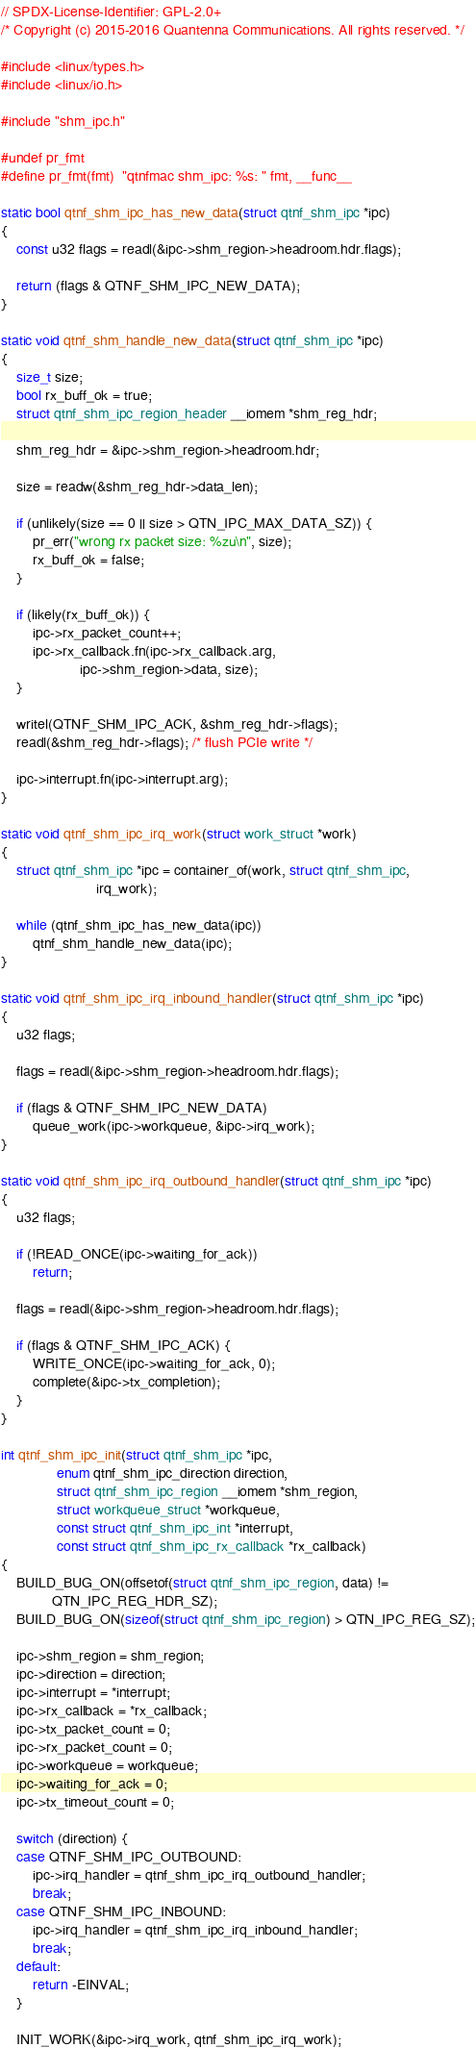<code> <loc_0><loc_0><loc_500><loc_500><_C_>// SPDX-License-Identifier: GPL-2.0+
/* Copyright (c) 2015-2016 Quantenna Communications. All rights reserved. */

#include <linux/types.h>
#include <linux/io.h>

#include "shm_ipc.h"

#undef pr_fmt
#define pr_fmt(fmt)	"qtnfmac shm_ipc: %s: " fmt, __func__

static bool qtnf_shm_ipc_has_new_data(struct qtnf_shm_ipc *ipc)
{
	const u32 flags = readl(&ipc->shm_region->headroom.hdr.flags);

	return (flags & QTNF_SHM_IPC_NEW_DATA);
}

static void qtnf_shm_handle_new_data(struct qtnf_shm_ipc *ipc)
{
	size_t size;
	bool rx_buff_ok = true;
	struct qtnf_shm_ipc_region_header __iomem *shm_reg_hdr;

	shm_reg_hdr = &ipc->shm_region->headroom.hdr;

	size = readw(&shm_reg_hdr->data_len);

	if (unlikely(size == 0 || size > QTN_IPC_MAX_DATA_SZ)) {
		pr_err("wrong rx packet size: %zu\n", size);
		rx_buff_ok = false;
	}

	if (likely(rx_buff_ok)) {
		ipc->rx_packet_count++;
		ipc->rx_callback.fn(ipc->rx_callback.arg,
				    ipc->shm_region->data, size);
	}

	writel(QTNF_SHM_IPC_ACK, &shm_reg_hdr->flags);
	readl(&shm_reg_hdr->flags); /* flush PCIe write */

	ipc->interrupt.fn(ipc->interrupt.arg);
}

static void qtnf_shm_ipc_irq_work(struct work_struct *work)
{
	struct qtnf_shm_ipc *ipc = container_of(work, struct qtnf_shm_ipc,
						irq_work);

	while (qtnf_shm_ipc_has_new_data(ipc))
		qtnf_shm_handle_new_data(ipc);
}

static void qtnf_shm_ipc_irq_inbound_handler(struct qtnf_shm_ipc *ipc)
{
	u32 flags;

	flags = readl(&ipc->shm_region->headroom.hdr.flags);

	if (flags & QTNF_SHM_IPC_NEW_DATA)
		queue_work(ipc->workqueue, &ipc->irq_work);
}

static void qtnf_shm_ipc_irq_outbound_handler(struct qtnf_shm_ipc *ipc)
{
	u32 flags;

	if (!READ_ONCE(ipc->waiting_for_ack))
		return;

	flags = readl(&ipc->shm_region->headroom.hdr.flags);

	if (flags & QTNF_SHM_IPC_ACK) {
		WRITE_ONCE(ipc->waiting_for_ack, 0);
		complete(&ipc->tx_completion);
	}
}

int qtnf_shm_ipc_init(struct qtnf_shm_ipc *ipc,
		      enum qtnf_shm_ipc_direction direction,
		      struct qtnf_shm_ipc_region __iomem *shm_region,
		      struct workqueue_struct *workqueue,
		      const struct qtnf_shm_ipc_int *interrupt,
		      const struct qtnf_shm_ipc_rx_callback *rx_callback)
{
	BUILD_BUG_ON(offsetof(struct qtnf_shm_ipc_region, data) !=
		     QTN_IPC_REG_HDR_SZ);
	BUILD_BUG_ON(sizeof(struct qtnf_shm_ipc_region) > QTN_IPC_REG_SZ);

	ipc->shm_region = shm_region;
	ipc->direction = direction;
	ipc->interrupt = *interrupt;
	ipc->rx_callback = *rx_callback;
	ipc->tx_packet_count = 0;
	ipc->rx_packet_count = 0;
	ipc->workqueue = workqueue;
	ipc->waiting_for_ack = 0;
	ipc->tx_timeout_count = 0;

	switch (direction) {
	case QTNF_SHM_IPC_OUTBOUND:
		ipc->irq_handler = qtnf_shm_ipc_irq_outbound_handler;
		break;
	case QTNF_SHM_IPC_INBOUND:
		ipc->irq_handler = qtnf_shm_ipc_irq_inbound_handler;
		break;
	default:
		return -EINVAL;
	}

	INIT_WORK(&ipc->irq_work, qtnf_shm_ipc_irq_work);</code> 